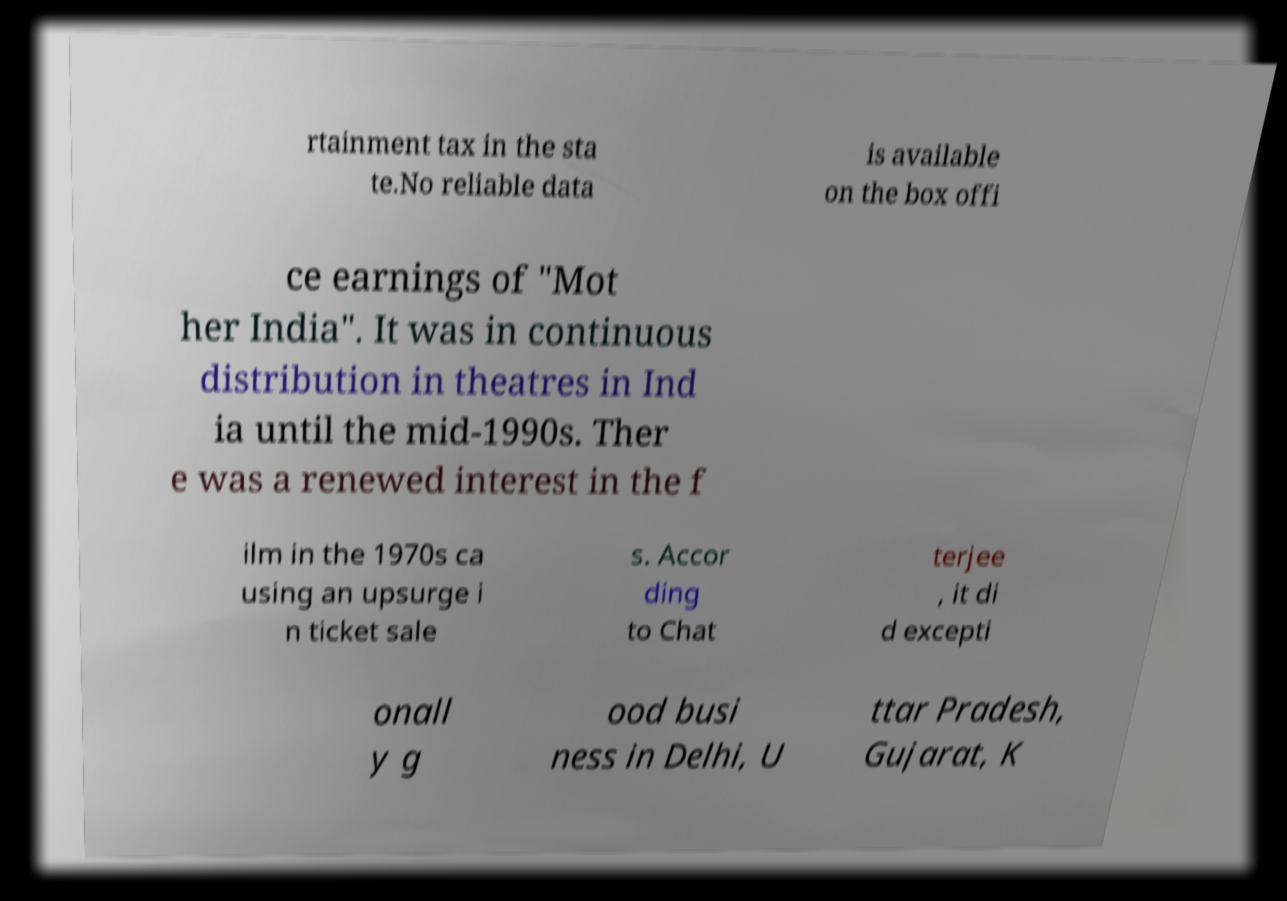Could you assist in decoding the text presented in this image and type it out clearly? rtainment tax in the sta te.No reliable data is available on the box offi ce earnings of "Mot her India". It was in continuous distribution in theatres in Ind ia until the mid-1990s. Ther e was a renewed interest in the f ilm in the 1970s ca using an upsurge i n ticket sale s. Accor ding to Chat terjee , it di d excepti onall y g ood busi ness in Delhi, U ttar Pradesh, Gujarat, K 